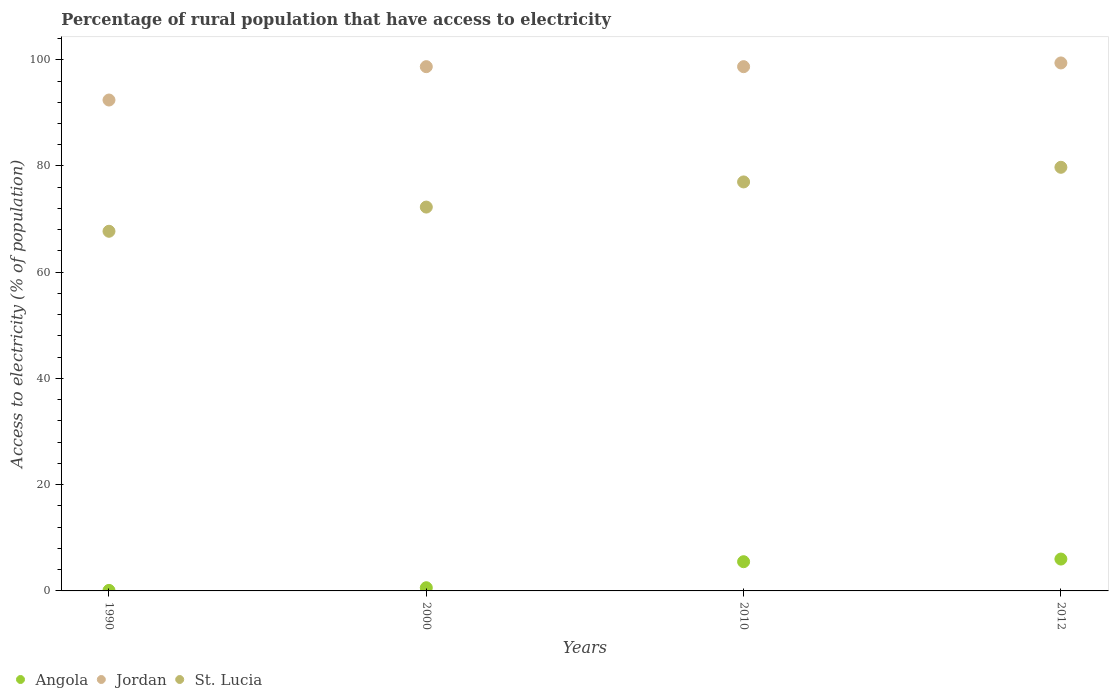How many different coloured dotlines are there?
Your answer should be very brief. 3. Across all years, what is the maximum percentage of rural population that have access to electricity in St. Lucia?
Make the answer very short. 79.75. Across all years, what is the minimum percentage of rural population that have access to electricity in St. Lucia?
Give a very brief answer. 67.71. In which year was the percentage of rural population that have access to electricity in St. Lucia maximum?
Offer a terse response. 2012. What is the total percentage of rural population that have access to electricity in Jordan in the graph?
Your response must be concise. 389.22. What is the difference between the percentage of rural population that have access to electricity in St. Lucia in 1990 and that in 2010?
Ensure brevity in your answer.  -9.29. What is the difference between the percentage of rural population that have access to electricity in St. Lucia in 2000 and the percentage of rural population that have access to electricity in Angola in 2010?
Provide a succinct answer. 66.77. What is the average percentage of rural population that have access to electricity in Jordan per year?
Your answer should be compact. 97.3. In the year 2010, what is the difference between the percentage of rural population that have access to electricity in St. Lucia and percentage of rural population that have access to electricity in Jordan?
Offer a very short reply. -21.7. In how many years, is the percentage of rural population that have access to electricity in Jordan greater than 24 %?
Give a very brief answer. 4. What is the ratio of the percentage of rural population that have access to electricity in St. Lucia in 1990 to that in 2010?
Make the answer very short. 0.88. Is the difference between the percentage of rural population that have access to electricity in St. Lucia in 2000 and 2010 greater than the difference between the percentage of rural population that have access to electricity in Jordan in 2000 and 2010?
Provide a succinct answer. No. What is the difference between the highest and the second highest percentage of rural population that have access to electricity in Angola?
Ensure brevity in your answer.  0.5. What is the difference between the highest and the lowest percentage of rural population that have access to electricity in Jordan?
Provide a succinct answer. 6.98. In how many years, is the percentage of rural population that have access to electricity in St. Lucia greater than the average percentage of rural population that have access to electricity in St. Lucia taken over all years?
Give a very brief answer. 2. Is the percentage of rural population that have access to electricity in Angola strictly greater than the percentage of rural population that have access to electricity in St. Lucia over the years?
Give a very brief answer. No. Is the percentage of rural population that have access to electricity in Jordan strictly less than the percentage of rural population that have access to electricity in Angola over the years?
Make the answer very short. No. How many dotlines are there?
Give a very brief answer. 3. Are the values on the major ticks of Y-axis written in scientific E-notation?
Your answer should be compact. No. Does the graph contain grids?
Make the answer very short. No. How are the legend labels stacked?
Offer a very short reply. Horizontal. What is the title of the graph?
Your answer should be very brief. Percentage of rural population that have access to electricity. What is the label or title of the Y-axis?
Provide a short and direct response. Access to electricity (% of population). What is the Access to electricity (% of population) of Angola in 1990?
Your response must be concise. 0.1. What is the Access to electricity (% of population) in Jordan in 1990?
Offer a terse response. 92.42. What is the Access to electricity (% of population) in St. Lucia in 1990?
Offer a terse response. 67.71. What is the Access to electricity (% of population) in Angola in 2000?
Provide a short and direct response. 0.6. What is the Access to electricity (% of population) in Jordan in 2000?
Ensure brevity in your answer.  98.7. What is the Access to electricity (% of population) of St. Lucia in 2000?
Give a very brief answer. 72.27. What is the Access to electricity (% of population) in Angola in 2010?
Your answer should be very brief. 5.5. What is the Access to electricity (% of population) in Jordan in 2010?
Give a very brief answer. 98.7. What is the Access to electricity (% of population) of Angola in 2012?
Offer a very short reply. 6. What is the Access to electricity (% of population) in Jordan in 2012?
Keep it short and to the point. 99.4. What is the Access to electricity (% of population) of St. Lucia in 2012?
Provide a succinct answer. 79.75. Across all years, what is the maximum Access to electricity (% of population) in Angola?
Ensure brevity in your answer.  6. Across all years, what is the maximum Access to electricity (% of population) in Jordan?
Keep it short and to the point. 99.4. Across all years, what is the maximum Access to electricity (% of population) of St. Lucia?
Keep it short and to the point. 79.75. Across all years, what is the minimum Access to electricity (% of population) of Jordan?
Give a very brief answer. 92.42. Across all years, what is the minimum Access to electricity (% of population) of St. Lucia?
Offer a very short reply. 67.71. What is the total Access to electricity (% of population) in Jordan in the graph?
Your response must be concise. 389.22. What is the total Access to electricity (% of population) of St. Lucia in the graph?
Give a very brief answer. 296.73. What is the difference between the Access to electricity (% of population) of Angola in 1990 and that in 2000?
Offer a terse response. -0.5. What is the difference between the Access to electricity (% of population) in Jordan in 1990 and that in 2000?
Offer a very short reply. -6.28. What is the difference between the Access to electricity (% of population) of St. Lucia in 1990 and that in 2000?
Your answer should be very brief. -4.55. What is the difference between the Access to electricity (% of population) in Jordan in 1990 and that in 2010?
Your answer should be very brief. -6.28. What is the difference between the Access to electricity (% of population) in St. Lucia in 1990 and that in 2010?
Your answer should be very brief. -9.29. What is the difference between the Access to electricity (% of population) in Jordan in 1990 and that in 2012?
Offer a terse response. -6.98. What is the difference between the Access to electricity (% of population) in St. Lucia in 1990 and that in 2012?
Give a very brief answer. -12.04. What is the difference between the Access to electricity (% of population) in St. Lucia in 2000 and that in 2010?
Ensure brevity in your answer.  -4.74. What is the difference between the Access to electricity (% of population) of St. Lucia in 2000 and that in 2012?
Your answer should be very brief. -7.49. What is the difference between the Access to electricity (% of population) of Angola in 2010 and that in 2012?
Keep it short and to the point. -0.5. What is the difference between the Access to electricity (% of population) in St. Lucia in 2010 and that in 2012?
Provide a succinct answer. -2.75. What is the difference between the Access to electricity (% of population) of Angola in 1990 and the Access to electricity (% of population) of Jordan in 2000?
Provide a succinct answer. -98.6. What is the difference between the Access to electricity (% of population) of Angola in 1990 and the Access to electricity (% of population) of St. Lucia in 2000?
Your answer should be compact. -72.17. What is the difference between the Access to electricity (% of population) of Jordan in 1990 and the Access to electricity (% of population) of St. Lucia in 2000?
Offer a terse response. 20.15. What is the difference between the Access to electricity (% of population) of Angola in 1990 and the Access to electricity (% of population) of Jordan in 2010?
Ensure brevity in your answer.  -98.6. What is the difference between the Access to electricity (% of population) in Angola in 1990 and the Access to electricity (% of population) in St. Lucia in 2010?
Provide a short and direct response. -76.9. What is the difference between the Access to electricity (% of population) in Jordan in 1990 and the Access to electricity (% of population) in St. Lucia in 2010?
Your answer should be compact. 15.42. What is the difference between the Access to electricity (% of population) of Angola in 1990 and the Access to electricity (% of population) of Jordan in 2012?
Provide a succinct answer. -99.3. What is the difference between the Access to electricity (% of population) of Angola in 1990 and the Access to electricity (% of population) of St. Lucia in 2012?
Offer a terse response. -79.65. What is the difference between the Access to electricity (% of population) of Jordan in 1990 and the Access to electricity (% of population) of St. Lucia in 2012?
Provide a succinct answer. 12.67. What is the difference between the Access to electricity (% of population) of Angola in 2000 and the Access to electricity (% of population) of Jordan in 2010?
Make the answer very short. -98.1. What is the difference between the Access to electricity (% of population) of Angola in 2000 and the Access to electricity (% of population) of St. Lucia in 2010?
Keep it short and to the point. -76.4. What is the difference between the Access to electricity (% of population) of Jordan in 2000 and the Access to electricity (% of population) of St. Lucia in 2010?
Offer a terse response. 21.7. What is the difference between the Access to electricity (% of population) of Angola in 2000 and the Access to electricity (% of population) of Jordan in 2012?
Provide a succinct answer. -98.8. What is the difference between the Access to electricity (% of population) of Angola in 2000 and the Access to electricity (% of population) of St. Lucia in 2012?
Your answer should be compact. -79.15. What is the difference between the Access to electricity (% of population) of Jordan in 2000 and the Access to electricity (% of population) of St. Lucia in 2012?
Give a very brief answer. 18.95. What is the difference between the Access to electricity (% of population) of Angola in 2010 and the Access to electricity (% of population) of Jordan in 2012?
Provide a succinct answer. -93.9. What is the difference between the Access to electricity (% of population) in Angola in 2010 and the Access to electricity (% of population) in St. Lucia in 2012?
Offer a terse response. -74.25. What is the difference between the Access to electricity (% of population) of Jordan in 2010 and the Access to electricity (% of population) of St. Lucia in 2012?
Offer a very short reply. 18.95. What is the average Access to electricity (% of population) in Angola per year?
Your answer should be compact. 3.05. What is the average Access to electricity (% of population) of Jordan per year?
Offer a terse response. 97.3. What is the average Access to electricity (% of population) of St. Lucia per year?
Your answer should be compact. 74.18. In the year 1990, what is the difference between the Access to electricity (% of population) of Angola and Access to electricity (% of population) of Jordan?
Offer a very short reply. -92.32. In the year 1990, what is the difference between the Access to electricity (% of population) of Angola and Access to electricity (% of population) of St. Lucia?
Provide a succinct answer. -67.61. In the year 1990, what is the difference between the Access to electricity (% of population) of Jordan and Access to electricity (% of population) of St. Lucia?
Keep it short and to the point. 24.71. In the year 2000, what is the difference between the Access to electricity (% of population) in Angola and Access to electricity (% of population) in Jordan?
Provide a short and direct response. -98.1. In the year 2000, what is the difference between the Access to electricity (% of population) in Angola and Access to electricity (% of population) in St. Lucia?
Ensure brevity in your answer.  -71.67. In the year 2000, what is the difference between the Access to electricity (% of population) in Jordan and Access to electricity (% of population) in St. Lucia?
Ensure brevity in your answer.  26.43. In the year 2010, what is the difference between the Access to electricity (% of population) of Angola and Access to electricity (% of population) of Jordan?
Provide a short and direct response. -93.2. In the year 2010, what is the difference between the Access to electricity (% of population) of Angola and Access to electricity (% of population) of St. Lucia?
Provide a short and direct response. -71.5. In the year 2010, what is the difference between the Access to electricity (% of population) of Jordan and Access to electricity (% of population) of St. Lucia?
Offer a very short reply. 21.7. In the year 2012, what is the difference between the Access to electricity (% of population) in Angola and Access to electricity (% of population) in Jordan?
Provide a succinct answer. -93.4. In the year 2012, what is the difference between the Access to electricity (% of population) of Angola and Access to electricity (% of population) of St. Lucia?
Provide a short and direct response. -73.75. In the year 2012, what is the difference between the Access to electricity (% of population) in Jordan and Access to electricity (% of population) in St. Lucia?
Provide a short and direct response. 19.65. What is the ratio of the Access to electricity (% of population) in Jordan in 1990 to that in 2000?
Your answer should be compact. 0.94. What is the ratio of the Access to electricity (% of population) of St. Lucia in 1990 to that in 2000?
Give a very brief answer. 0.94. What is the ratio of the Access to electricity (% of population) in Angola in 1990 to that in 2010?
Provide a succinct answer. 0.02. What is the ratio of the Access to electricity (% of population) of Jordan in 1990 to that in 2010?
Keep it short and to the point. 0.94. What is the ratio of the Access to electricity (% of population) of St. Lucia in 1990 to that in 2010?
Make the answer very short. 0.88. What is the ratio of the Access to electricity (% of population) of Angola in 1990 to that in 2012?
Your response must be concise. 0.02. What is the ratio of the Access to electricity (% of population) in Jordan in 1990 to that in 2012?
Give a very brief answer. 0.93. What is the ratio of the Access to electricity (% of population) of St. Lucia in 1990 to that in 2012?
Offer a very short reply. 0.85. What is the ratio of the Access to electricity (% of population) of Angola in 2000 to that in 2010?
Give a very brief answer. 0.11. What is the ratio of the Access to electricity (% of population) of St. Lucia in 2000 to that in 2010?
Give a very brief answer. 0.94. What is the ratio of the Access to electricity (% of population) of Angola in 2000 to that in 2012?
Your answer should be compact. 0.1. What is the ratio of the Access to electricity (% of population) in Jordan in 2000 to that in 2012?
Keep it short and to the point. 0.99. What is the ratio of the Access to electricity (% of population) in St. Lucia in 2000 to that in 2012?
Offer a very short reply. 0.91. What is the ratio of the Access to electricity (% of population) of Angola in 2010 to that in 2012?
Give a very brief answer. 0.92. What is the ratio of the Access to electricity (% of population) of St. Lucia in 2010 to that in 2012?
Your answer should be very brief. 0.97. What is the difference between the highest and the second highest Access to electricity (% of population) in Angola?
Your answer should be very brief. 0.5. What is the difference between the highest and the second highest Access to electricity (% of population) of Jordan?
Make the answer very short. 0.7. What is the difference between the highest and the second highest Access to electricity (% of population) of St. Lucia?
Give a very brief answer. 2.75. What is the difference between the highest and the lowest Access to electricity (% of population) in Angola?
Your answer should be very brief. 5.9. What is the difference between the highest and the lowest Access to electricity (% of population) in Jordan?
Provide a short and direct response. 6.98. What is the difference between the highest and the lowest Access to electricity (% of population) in St. Lucia?
Your answer should be compact. 12.04. 